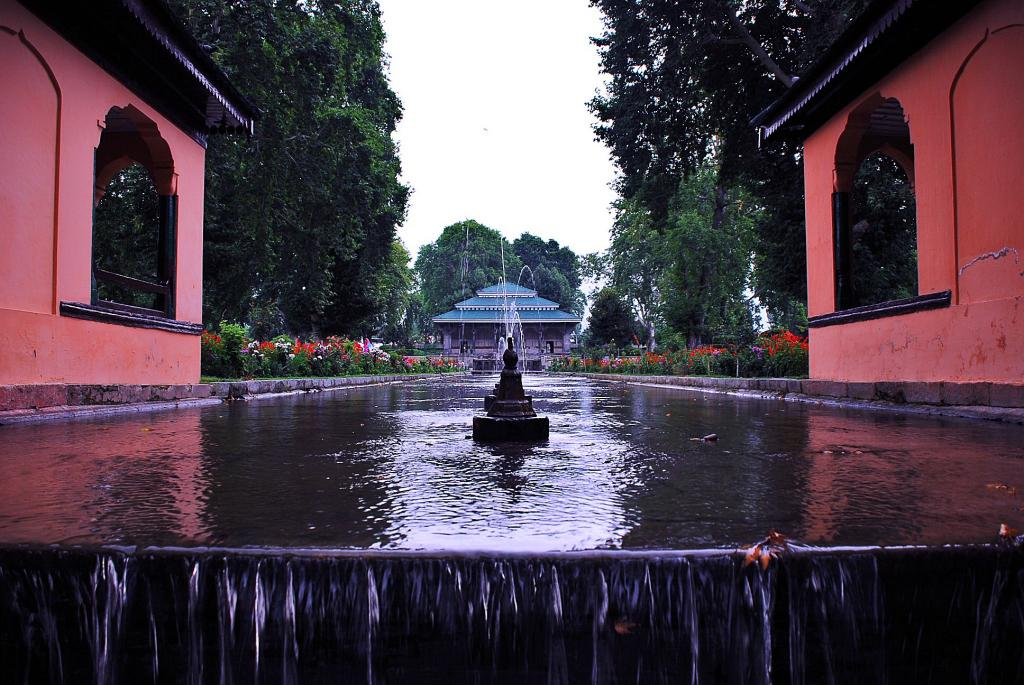What is the main feature in the image? There is a fountain in the image. What can be seen flowing from the fountain? There is water visible in the image. What type of structures are present in the image? There are houses with roofs in the image. What type of vegetation can be seen in the image? There is a group of plants with flowers and a group of trees in the image. What is the condition of the sky in the image? The sky is visible in the image and appears cloudy. Can you tell me how many carpenters are working on the roof of the house in the image? There is no carpenter present in the image, and therefore no information about their work on the roof of the house. What is the girl doing in the image? There is no girl present in the image, so it is not possible to describe her actions. 